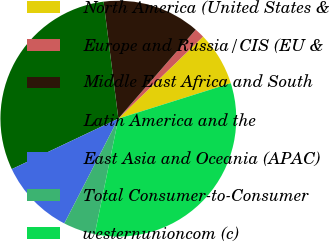Convert chart to OTSL. <chart><loc_0><loc_0><loc_500><loc_500><pie_chart><fcel>North America (United States &<fcel>Europe and Russia/CIS (EU &<fcel>Middle East Africa and South<fcel>Latin America and the<fcel>East Asia and Oceania (APAC)<fcel>Total Consumer-to-Consumer<fcel>westernunioncom (c)<nl><fcel>7.38%<fcel>1.37%<fcel>13.39%<fcel>30.05%<fcel>10.38%<fcel>4.37%<fcel>33.06%<nl></chart> 